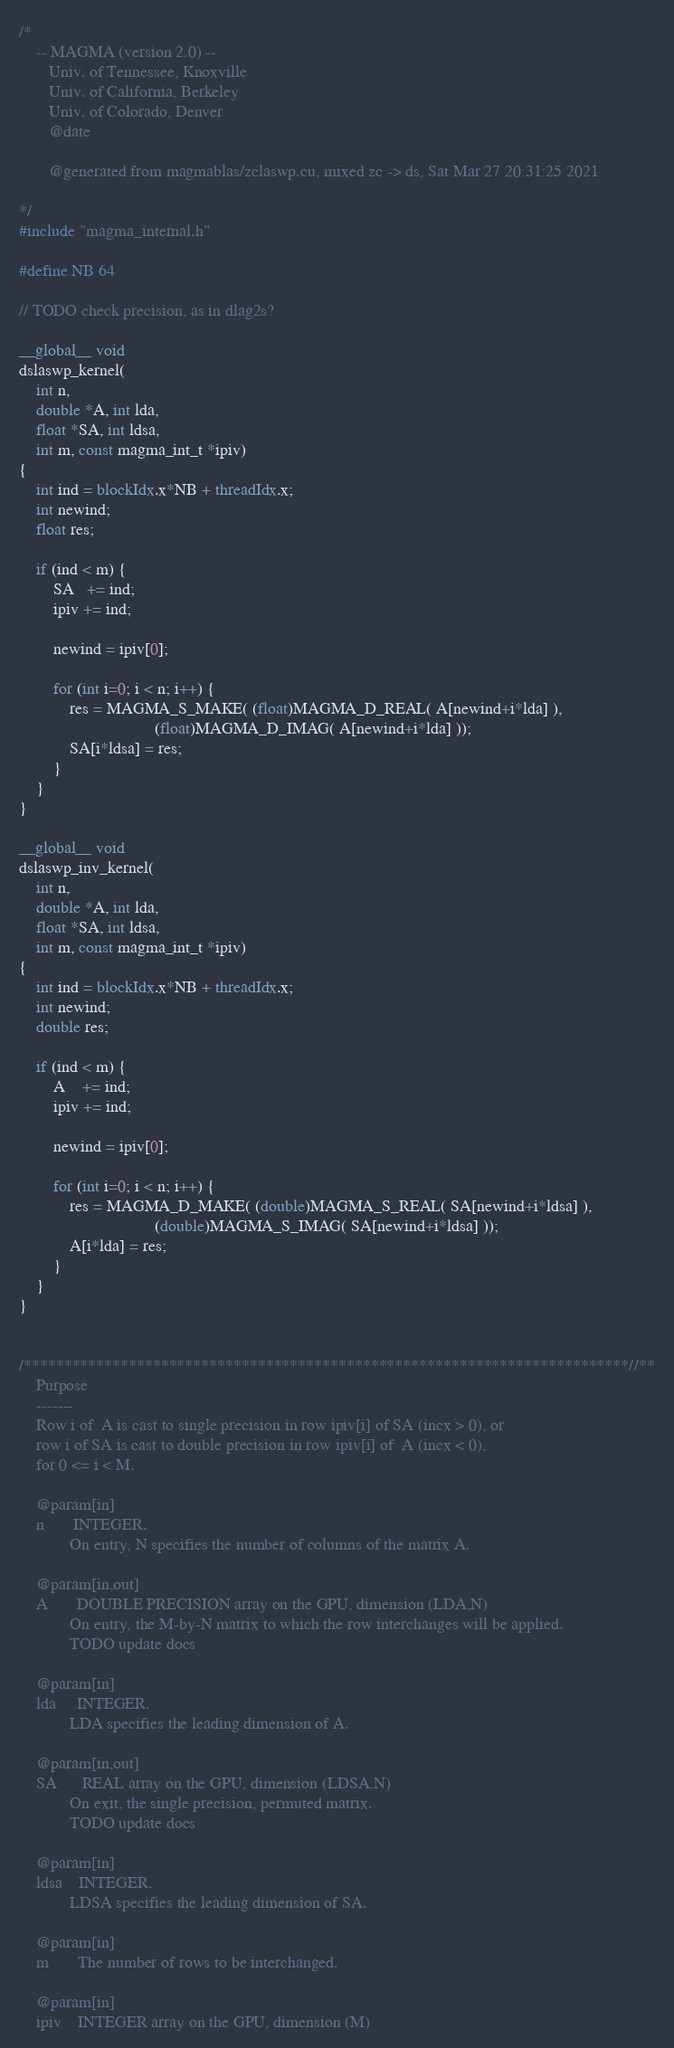<code> <loc_0><loc_0><loc_500><loc_500><_Cuda_>/*
    -- MAGMA (version 2.0) --
       Univ. of Tennessee, Knoxville
       Univ. of California, Berkeley
       Univ. of Colorado, Denver
       @date

       @generated from magmablas/zclaswp.cu, mixed zc -> ds, Sat Mar 27 20:31:25 2021

*/
#include "magma_internal.h"

#define NB 64

// TODO check precision, as in dlag2s?

__global__ void
dslaswp_kernel(
    int n,
    double *A, int lda,
    float *SA, int ldsa,
    int m, const magma_int_t *ipiv)
{
    int ind = blockIdx.x*NB + threadIdx.x;
    int newind;
    float res;
    
    if (ind < m) {
        SA   += ind;
        ipiv += ind;
        
        newind = ipiv[0];
        
        for (int i=0; i < n; i++) {
            res = MAGMA_S_MAKE( (float)MAGMA_D_REAL( A[newind+i*lda] ),
                                (float)MAGMA_D_IMAG( A[newind+i*lda] ));
            SA[i*ldsa] = res; 
        }
    }
}

__global__ void
dslaswp_inv_kernel(
    int n,
    double *A, int lda,
    float *SA, int ldsa,
    int m, const magma_int_t *ipiv)
{
    int ind = blockIdx.x*NB + threadIdx.x;
    int newind;
    double res;

    if (ind < m) {
        A    += ind;
        ipiv += ind;

        newind = ipiv[0];

        for (int i=0; i < n; i++) {
            res = MAGMA_D_MAKE( (double)MAGMA_S_REAL( SA[newind+i*ldsa] ),
                                (double)MAGMA_S_IMAG( SA[newind+i*ldsa] ));
            A[i*lda] = res;
        }
    }
}


/***************************************************************************//**
    Purpose
    -------
    Row i of  A is cast to single precision in row ipiv[i] of SA (incx > 0), or
    row i of SA is cast to double precision in row ipiv[i] of  A (incx < 0),
    for 0 <= i < M.

    @param[in]
    n       INTEGER.
            On entry, N specifies the number of columns of the matrix A.

    @param[in,out]
    A       DOUBLE PRECISION array on the GPU, dimension (LDA,N)
            On entry, the M-by-N matrix to which the row interchanges will be applied.
            TODO update docs

    @param[in]
    lda     INTEGER.
            LDA specifies the leading dimension of A.

    @param[in,out]
    SA      REAL array on the GPU, dimension (LDSA,N)
            On exit, the single precision, permuted matrix.
            TODO update docs

    @param[in]
    ldsa    INTEGER.
            LDSA specifies the leading dimension of SA.
        
    @param[in]
    m       The number of rows to be interchanged.

    @param[in]
    ipiv    INTEGER array on the GPU, dimension (M)</code> 